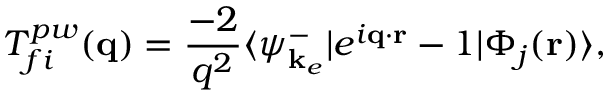<formula> <loc_0><loc_0><loc_500><loc_500>T _ { f i } ^ { p w } ( q ) = \frac { - 2 } { q ^ { 2 } } \langle \psi _ { k _ { e } } ^ { - } | e ^ { i q \cdot r } - 1 | \Phi _ { j } ( r ) \rangle ,</formula> 